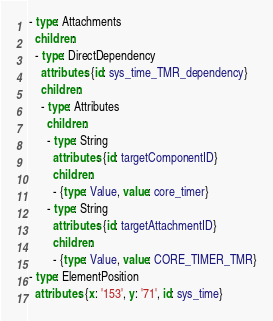<code> <loc_0><loc_0><loc_500><loc_500><_YAML_>- type: Attachments
  children:
  - type: DirectDependency
    attributes: {id: sys_time_TMR_dependency}
    children:
    - type: Attributes
      children:
      - type: String
        attributes: {id: targetComponentID}
        children:
        - {type: Value, value: core_timer}
      - type: String
        attributes: {id: targetAttachmentID}
        children:
        - {type: Value, value: CORE_TIMER_TMR}
- type: ElementPosition
  attributes: {x: '153', y: '71', id: sys_time}
</code> 